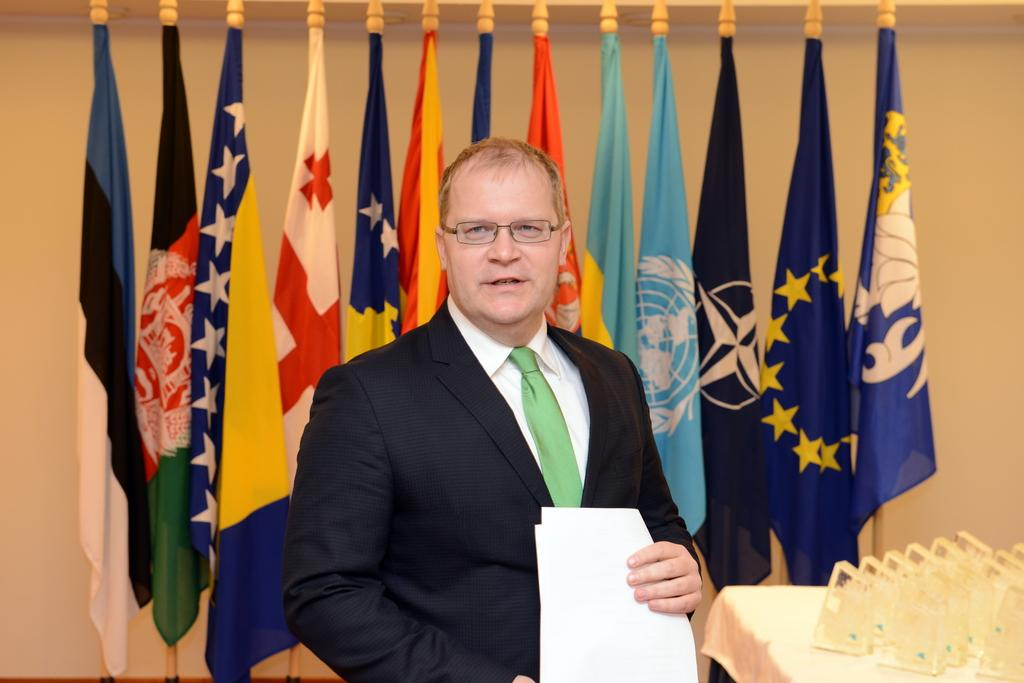What is the main subject of the image? There is a person standing in the center of the image. What is the person wearing? The person is wearing a suit. What is the person holding in his hand? The person is holding a paper in his hand. What can be seen in the background of the image? There are flags and a wall in the background of the image. How many acts are being performed by the person in the image? There is no indication of any performance or act in the image; the person is simply standing and holding a paper. 